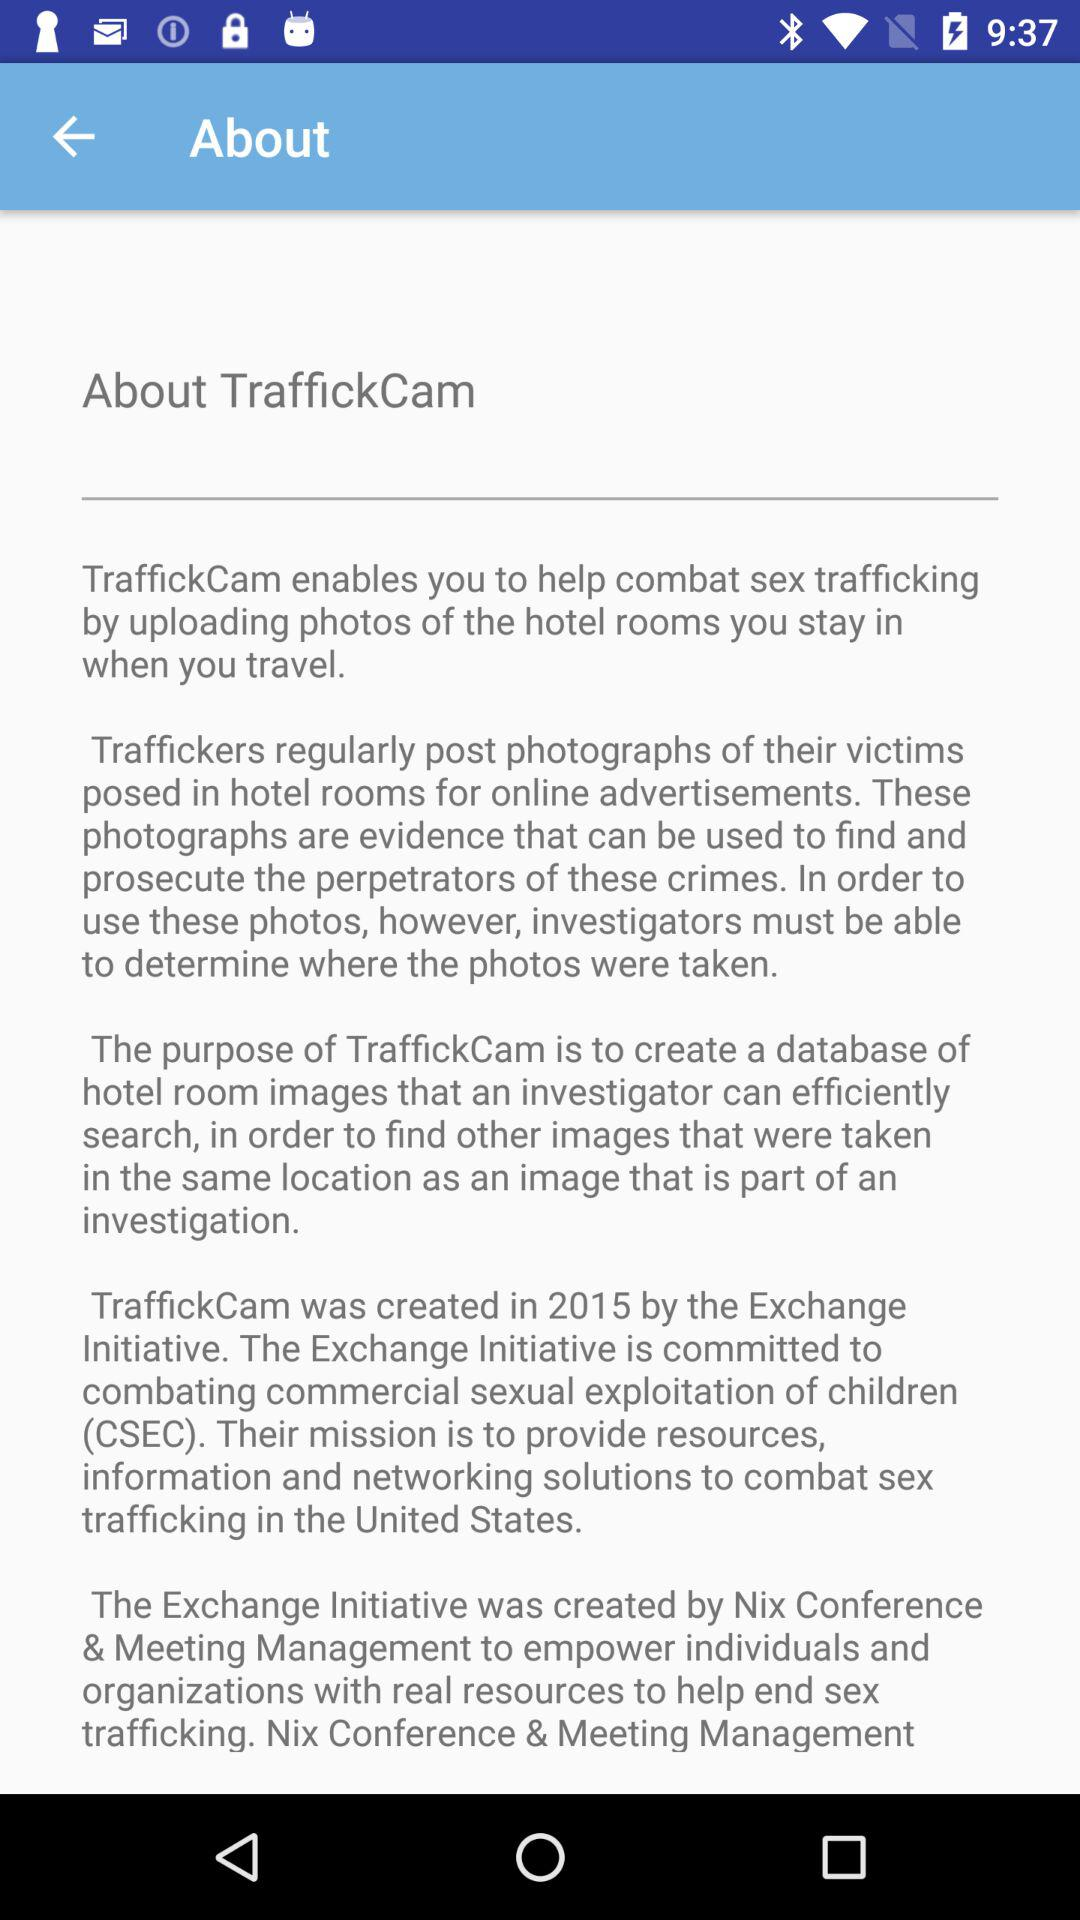How is the application "TraffickCam" useful? The application enables users to help combat sex trafficking by uploading photos of the hotel rooms they stay in when they travel. 